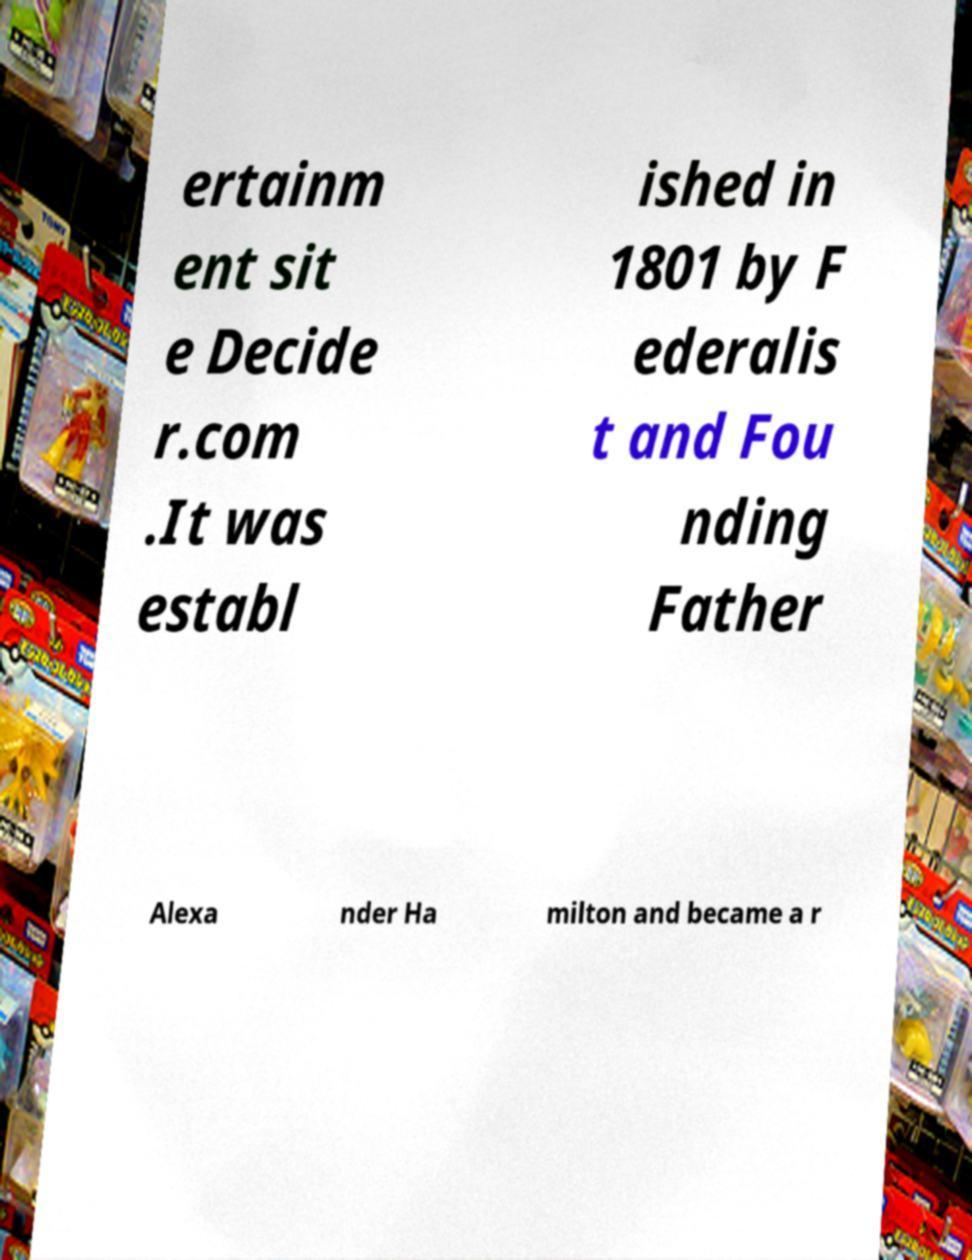Could you assist in decoding the text presented in this image and type it out clearly? ertainm ent sit e Decide r.com .It was establ ished in 1801 by F ederalis t and Fou nding Father Alexa nder Ha milton and became a r 